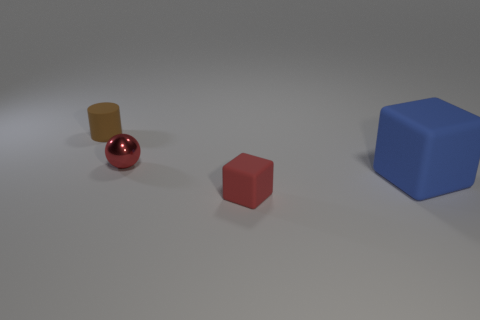There is a large object that is the same shape as the tiny red matte thing; what is its color? The large object that mirrors the shape of the small red sphere is blue. It stands out due to its saturated color and size in comparison to the other objects in the image. 